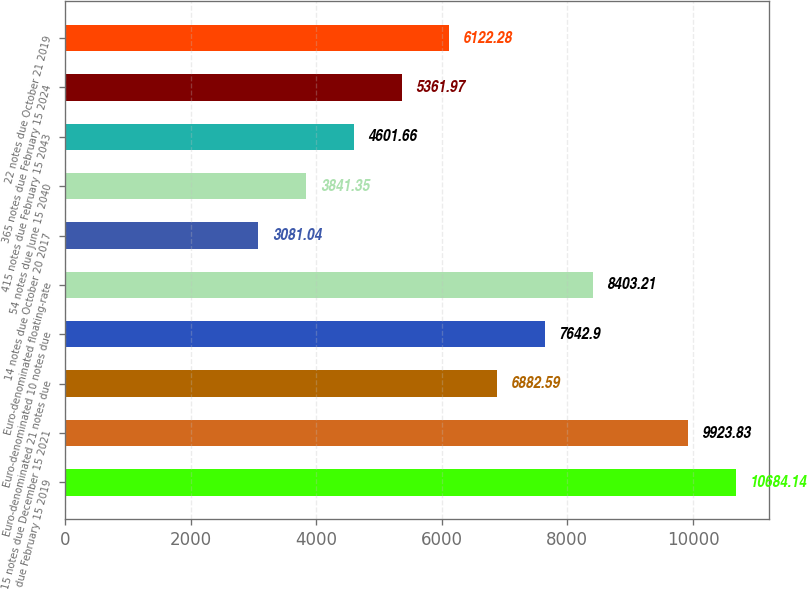Convert chart. <chart><loc_0><loc_0><loc_500><loc_500><bar_chart><fcel>565 notes due February 15 2019<fcel>315 notes due December 15 2021<fcel>Euro-denominated 21 notes due<fcel>Euro-denominated 10 notes due<fcel>Euro-denominated floating-rate<fcel>14 notes due October 20 2017<fcel>54 notes due June 15 2040<fcel>415 notes due February 15 2043<fcel>365 notes due February 15 2024<fcel>22 notes due October 21 2019<nl><fcel>10684.1<fcel>9923.83<fcel>6882.59<fcel>7642.9<fcel>8403.21<fcel>3081.04<fcel>3841.35<fcel>4601.66<fcel>5361.97<fcel>6122.28<nl></chart> 